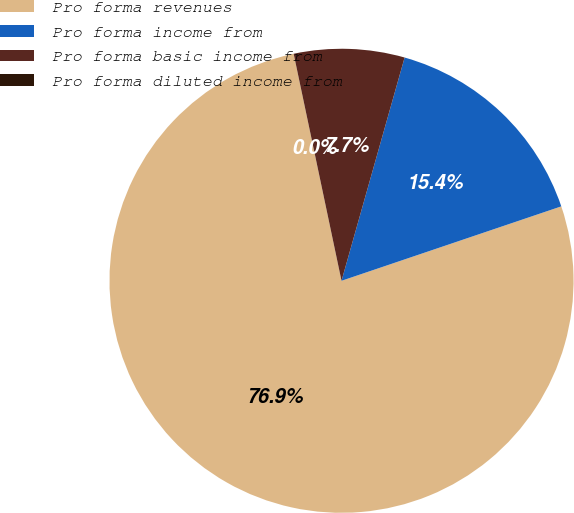Convert chart to OTSL. <chart><loc_0><loc_0><loc_500><loc_500><pie_chart><fcel>Pro forma revenues<fcel>Pro forma income from<fcel>Pro forma basic income from<fcel>Pro forma diluted income from<nl><fcel>76.89%<fcel>15.42%<fcel>7.69%<fcel>0.0%<nl></chart> 